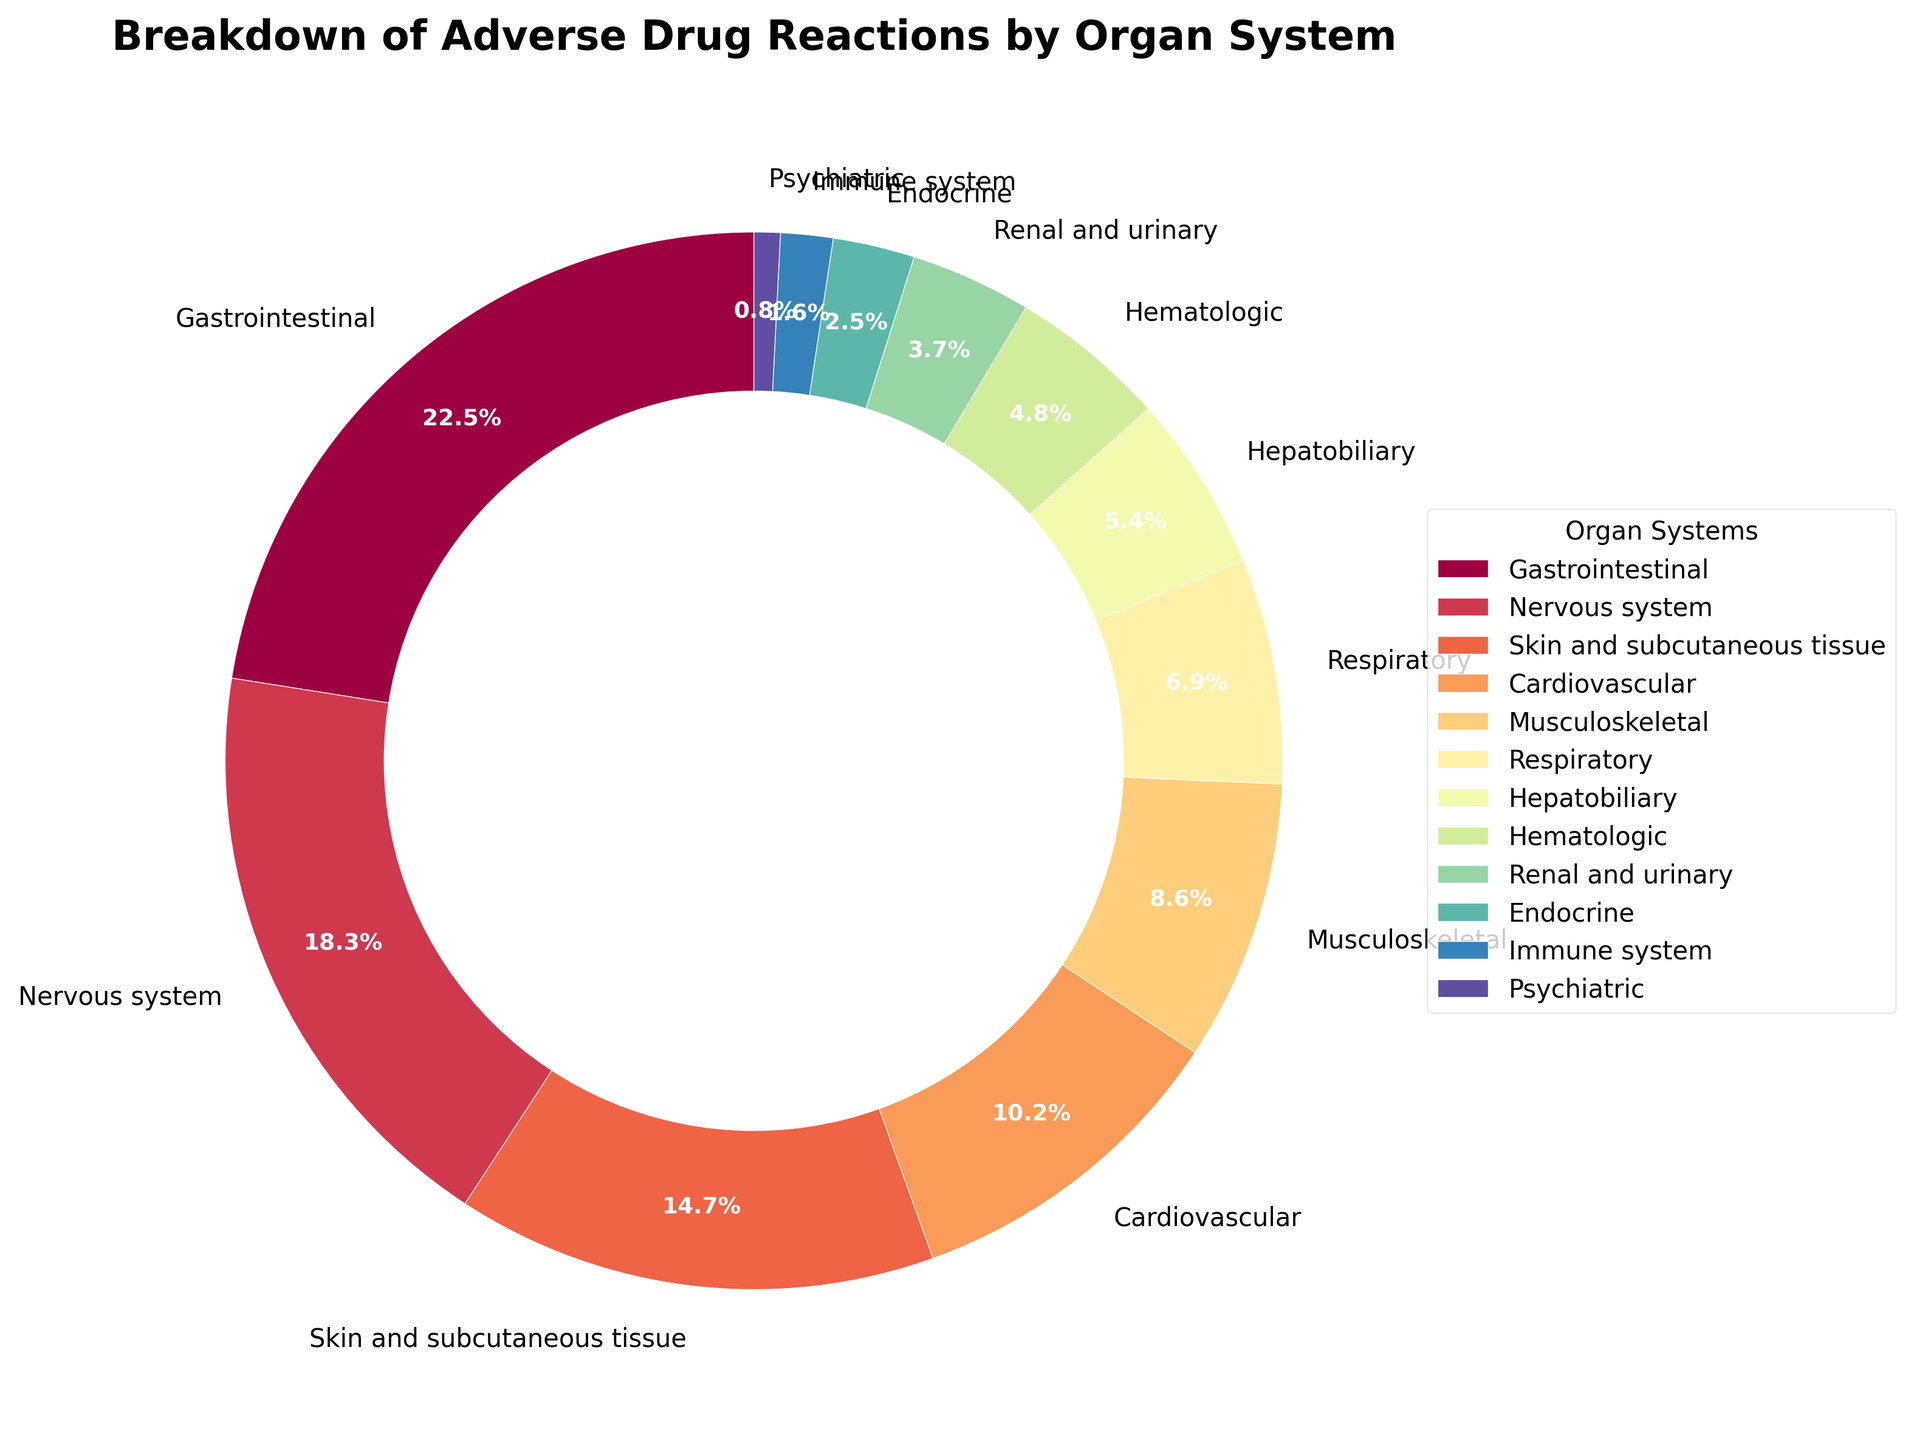Which organ system has the highest percentage of adverse drug reactions? The figure shows that the Gastrointestinal organ system has the largest section, indicating the highest percentage of adverse drug reactions.
Answer: Gastrointestinal What is the total percentage of adverse drug reactions for the Nervous system and Skin and subcutaneous tissue? Summing the percentages, Nervous system (18.3%) and Skin and subcutaneous tissue (14.7%) add up to 18.3 + 14.7 = 33.0%.
Answer: 33.0% Which organ systems have a percentage of adverse drug reactions lower than the Respiratory system (6.9%)? Comparing all the percentages, the Endocrine (2.5%), Immune system (1.6%), Psychiatric (0.8%), Renal and urinary (3.7%), Hepatobiliary (5.4%), and Hematologic (4.8%) have percentages lower than the Respiratory system.
Answer: Endocrine, Immune system, Psychiatric, Renal and urinary, Hepatobiliary, Hematologic Is the percentage of adverse drug reactions in the Cardiovascular system higher or lower than in the Musculoskeletal system? Comparing the two percentages, Cardiovascular (10.2%) is higher than Musculoskeletal (8.6%).
Answer: Higher What is the combined percentage of adverse drug reactions in the Hepatobiliary and Hematologic systems? Adding the percentages, Hepatobiliary (5.4%) and Hematologic (4.8%) gives 5.4 + 4.8 = 10.2%.
Answer: 10.2% Which organ system has the smallest percentage of adverse drug reactions, and what is it? The figure shows that the Psychiatric organ system has the smallest section, indicating the lowest percentage of adverse drug reactions at 0.8%.
Answer: Psychiatric, 0.8% Are the combined percentages of adverse drug reactions in the Gastrointestinal, Nervous system, and Skin and subcutaneous tissue over 50%? Summing the percentages, Gastrointestinal (22.5%), Nervous system (18.3%), and Skin and subcutaneous tissue (14.7%) add up to 22.5 + 18.3 + 14.7 = 55.5%, which is over 50%.
Answer: Yes, 55.5% How does the percentage of adverse drug reactions in the Immune system compare to that in the Renal and urinary systems? The Immune system (1.6%) has a lower percentage compared to the Renal and urinary (3.7%) system.
Answer: Lower Which organ systems have a percentage of adverse drug reactions between 5% and 10%? The percentages between 5% and 10% are Cardiovascular (10.2%), Respiratory (6.9%), and Hepatobiliary (5.4%).
Answer: Cardiovascular, Respiratory, Hepatobiliary What is the difference in percentage of adverse drug reactions between the Endocrine systems (2.5%) and the Cardiovascular system (10.2%)? Subtracting the percentages, Cardiovascular (10.2%) - Endocrine (2.5%) = 7.7%.
Answer: 7.7% 